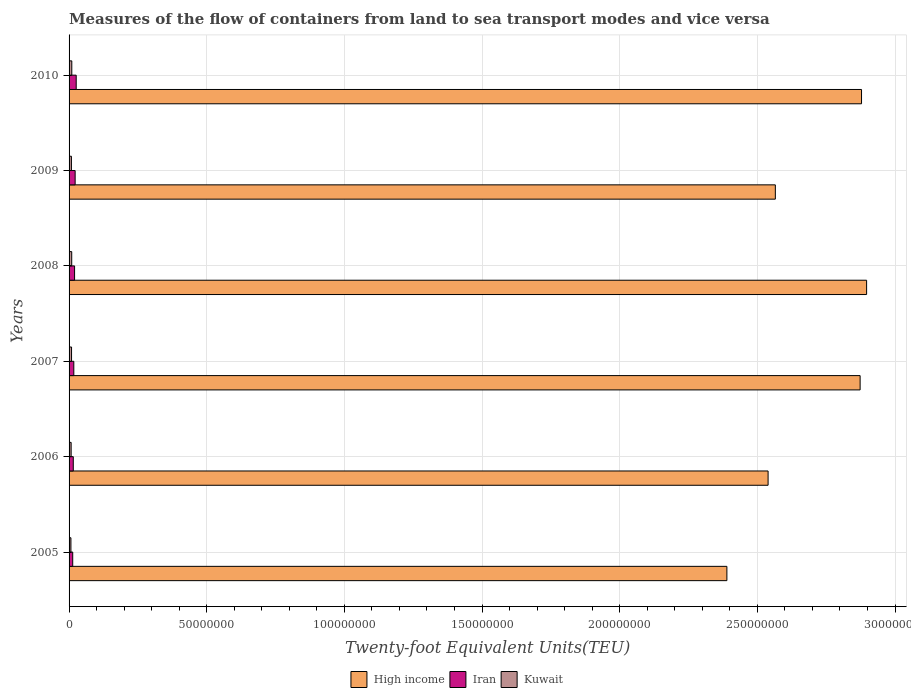How many different coloured bars are there?
Provide a succinct answer. 3. How many groups of bars are there?
Offer a terse response. 6. Are the number of bars per tick equal to the number of legend labels?
Ensure brevity in your answer.  Yes. Are the number of bars on each tick of the Y-axis equal?
Provide a succinct answer. Yes. How many bars are there on the 3rd tick from the top?
Provide a short and direct response. 3. What is the container port traffic in High income in 2006?
Give a very brief answer. 2.54e+08. Across all years, what is the maximum container port traffic in Iran?
Your answer should be very brief. 2.59e+06. Across all years, what is the minimum container port traffic in Kuwait?
Ensure brevity in your answer.  6.73e+05. In which year was the container port traffic in Kuwait maximum?
Make the answer very short. 2010. What is the total container port traffic in High income in the graph?
Provide a short and direct response. 1.61e+09. What is the difference between the container port traffic in Kuwait in 2008 and that in 2009?
Offer a very short reply. 1.08e+05. What is the difference between the container port traffic in High income in 2006 and the container port traffic in Iran in 2005?
Your answer should be compact. 2.53e+08. What is the average container port traffic in Kuwait per year?
Provide a short and direct response. 8.55e+05. In the year 2005, what is the difference between the container port traffic in Iran and container port traffic in Kuwait?
Your answer should be compact. 6.52e+05. In how many years, is the container port traffic in Iran greater than 20000000 TEU?
Your response must be concise. 0. What is the ratio of the container port traffic in High income in 2008 to that in 2009?
Offer a terse response. 1.13. Is the container port traffic in High income in 2006 less than that in 2009?
Provide a short and direct response. Yes. What is the difference between the highest and the second highest container port traffic in Kuwait?
Keep it short and to the point. 2.99e+04. What is the difference between the highest and the lowest container port traffic in Iran?
Give a very brief answer. 1.27e+06. In how many years, is the container port traffic in Iran greater than the average container port traffic in Iran taken over all years?
Provide a short and direct response. 3. Is the sum of the container port traffic in Kuwait in 2006 and 2009 greater than the maximum container port traffic in Iran across all years?
Ensure brevity in your answer.  No. What does the 2nd bar from the top in 2010 represents?
Offer a terse response. Iran. What does the 1st bar from the bottom in 2005 represents?
Offer a terse response. High income. Is it the case that in every year, the sum of the container port traffic in High income and container port traffic in Iran is greater than the container port traffic in Kuwait?
Keep it short and to the point. Yes. How many bars are there?
Ensure brevity in your answer.  18. Are all the bars in the graph horizontal?
Your response must be concise. Yes. How many years are there in the graph?
Give a very brief answer. 6. What is the difference between two consecutive major ticks on the X-axis?
Give a very brief answer. 5.00e+07. Does the graph contain any zero values?
Make the answer very short. No. Does the graph contain grids?
Give a very brief answer. Yes. Where does the legend appear in the graph?
Provide a short and direct response. Bottom center. What is the title of the graph?
Ensure brevity in your answer.  Measures of the flow of containers from land to sea transport modes and vice versa. Does "Kenya" appear as one of the legend labels in the graph?
Your answer should be compact. No. What is the label or title of the X-axis?
Provide a short and direct response. Twenty-foot Equivalent Units(TEU). What is the Twenty-foot Equivalent Units(TEU) in High income in 2005?
Ensure brevity in your answer.  2.39e+08. What is the Twenty-foot Equivalent Units(TEU) in Iran in 2005?
Offer a terse response. 1.33e+06. What is the Twenty-foot Equivalent Units(TEU) of Kuwait in 2005?
Offer a terse response. 6.73e+05. What is the Twenty-foot Equivalent Units(TEU) in High income in 2006?
Provide a short and direct response. 2.54e+08. What is the Twenty-foot Equivalent Units(TEU) of Iran in 2006?
Give a very brief answer. 1.53e+06. What is the Twenty-foot Equivalent Units(TEU) in Kuwait in 2006?
Keep it short and to the point. 7.50e+05. What is the Twenty-foot Equivalent Units(TEU) in High income in 2007?
Provide a succinct answer. 2.87e+08. What is the Twenty-foot Equivalent Units(TEU) of Iran in 2007?
Provide a succinct answer. 1.72e+06. What is the Twenty-foot Equivalent Units(TEU) of Kuwait in 2007?
Provide a short and direct response. 9.00e+05. What is the Twenty-foot Equivalent Units(TEU) in High income in 2008?
Keep it short and to the point. 2.90e+08. What is the Twenty-foot Equivalent Units(TEU) of Iran in 2008?
Your answer should be compact. 2.00e+06. What is the Twenty-foot Equivalent Units(TEU) in Kuwait in 2008?
Offer a very short reply. 9.62e+05. What is the Twenty-foot Equivalent Units(TEU) of High income in 2009?
Your answer should be compact. 2.57e+08. What is the Twenty-foot Equivalent Units(TEU) of Iran in 2009?
Your answer should be very brief. 2.21e+06. What is the Twenty-foot Equivalent Units(TEU) of Kuwait in 2009?
Your answer should be compact. 8.54e+05. What is the Twenty-foot Equivalent Units(TEU) of High income in 2010?
Provide a succinct answer. 2.88e+08. What is the Twenty-foot Equivalent Units(TEU) in Iran in 2010?
Offer a terse response. 2.59e+06. What is the Twenty-foot Equivalent Units(TEU) of Kuwait in 2010?
Provide a short and direct response. 9.92e+05. Across all years, what is the maximum Twenty-foot Equivalent Units(TEU) in High income?
Keep it short and to the point. 2.90e+08. Across all years, what is the maximum Twenty-foot Equivalent Units(TEU) of Iran?
Your response must be concise. 2.59e+06. Across all years, what is the maximum Twenty-foot Equivalent Units(TEU) of Kuwait?
Make the answer very short. 9.92e+05. Across all years, what is the minimum Twenty-foot Equivalent Units(TEU) of High income?
Your answer should be compact. 2.39e+08. Across all years, what is the minimum Twenty-foot Equivalent Units(TEU) in Iran?
Offer a terse response. 1.33e+06. Across all years, what is the minimum Twenty-foot Equivalent Units(TEU) of Kuwait?
Ensure brevity in your answer.  6.73e+05. What is the total Twenty-foot Equivalent Units(TEU) in High income in the graph?
Your response must be concise. 1.61e+09. What is the total Twenty-foot Equivalent Units(TEU) of Iran in the graph?
Your response must be concise. 1.14e+07. What is the total Twenty-foot Equivalent Units(TEU) of Kuwait in the graph?
Provide a short and direct response. 5.13e+06. What is the difference between the Twenty-foot Equivalent Units(TEU) of High income in 2005 and that in 2006?
Your answer should be very brief. -1.50e+07. What is the difference between the Twenty-foot Equivalent Units(TEU) of Iran in 2005 and that in 2006?
Offer a terse response. -2.03e+05. What is the difference between the Twenty-foot Equivalent Units(TEU) of Kuwait in 2005 and that in 2006?
Provide a short and direct response. -7.65e+04. What is the difference between the Twenty-foot Equivalent Units(TEU) in High income in 2005 and that in 2007?
Your answer should be compact. -4.84e+07. What is the difference between the Twenty-foot Equivalent Units(TEU) of Iran in 2005 and that in 2007?
Provide a succinct answer. -3.97e+05. What is the difference between the Twenty-foot Equivalent Units(TEU) of Kuwait in 2005 and that in 2007?
Offer a very short reply. -2.27e+05. What is the difference between the Twenty-foot Equivalent Units(TEU) of High income in 2005 and that in 2008?
Provide a succinct answer. -5.08e+07. What is the difference between the Twenty-foot Equivalent Units(TEU) of Iran in 2005 and that in 2008?
Your response must be concise. -6.75e+05. What is the difference between the Twenty-foot Equivalent Units(TEU) of Kuwait in 2005 and that in 2008?
Ensure brevity in your answer.  -2.88e+05. What is the difference between the Twenty-foot Equivalent Units(TEU) of High income in 2005 and that in 2009?
Your answer should be compact. -1.76e+07. What is the difference between the Twenty-foot Equivalent Units(TEU) in Iran in 2005 and that in 2009?
Offer a terse response. -8.81e+05. What is the difference between the Twenty-foot Equivalent Units(TEU) of Kuwait in 2005 and that in 2009?
Offer a terse response. -1.81e+05. What is the difference between the Twenty-foot Equivalent Units(TEU) in High income in 2005 and that in 2010?
Provide a succinct answer. -4.89e+07. What is the difference between the Twenty-foot Equivalent Units(TEU) of Iran in 2005 and that in 2010?
Offer a terse response. -1.27e+06. What is the difference between the Twenty-foot Equivalent Units(TEU) in Kuwait in 2005 and that in 2010?
Provide a succinct answer. -3.18e+05. What is the difference between the Twenty-foot Equivalent Units(TEU) in High income in 2006 and that in 2007?
Your response must be concise. -3.34e+07. What is the difference between the Twenty-foot Equivalent Units(TEU) of Iran in 2006 and that in 2007?
Your response must be concise. -1.94e+05. What is the difference between the Twenty-foot Equivalent Units(TEU) in Kuwait in 2006 and that in 2007?
Keep it short and to the point. -1.50e+05. What is the difference between the Twenty-foot Equivalent Units(TEU) of High income in 2006 and that in 2008?
Provide a short and direct response. -3.58e+07. What is the difference between the Twenty-foot Equivalent Units(TEU) of Iran in 2006 and that in 2008?
Give a very brief answer. -4.72e+05. What is the difference between the Twenty-foot Equivalent Units(TEU) in Kuwait in 2006 and that in 2008?
Offer a terse response. -2.12e+05. What is the difference between the Twenty-foot Equivalent Units(TEU) in High income in 2006 and that in 2009?
Your response must be concise. -2.63e+06. What is the difference between the Twenty-foot Equivalent Units(TEU) in Iran in 2006 and that in 2009?
Offer a terse response. -6.78e+05. What is the difference between the Twenty-foot Equivalent Units(TEU) of Kuwait in 2006 and that in 2009?
Give a very brief answer. -1.04e+05. What is the difference between the Twenty-foot Equivalent Units(TEU) in High income in 2006 and that in 2010?
Provide a succinct answer. -3.39e+07. What is the difference between the Twenty-foot Equivalent Units(TEU) of Iran in 2006 and that in 2010?
Ensure brevity in your answer.  -1.06e+06. What is the difference between the Twenty-foot Equivalent Units(TEU) in Kuwait in 2006 and that in 2010?
Provide a short and direct response. -2.42e+05. What is the difference between the Twenty-foot Equivalent Units(TEU) of High income in 2007 and that in 2008?
Provide a short and direct response. -2.36e+06. What is the difference between the Twenty-foot Equivalent Units(TEU) in Iran in 2007 and that in 2008?
Ensure brevity in your answer.  -2.78e+05. What is the difference between the Twenty-foot Equivalent Units(TEU) of Kuwait in 2007 and that in 2008?
Your answer should be compact. -6.17e+04. What is the difference between the Twenty-foot Equivalent Units(TEU) in High income in 2007 and that in 2009?
Make the answer very short. 3.08e+07. What is the difference between the Twenty-foot Equivalent Units(TEU) of Iran in 2007 and that in 2009?
Your answer should be compact. -4.84e+05. What is the difference between the Twenty-foot Equivalent Units(TEU) of Kuwait in 2007 and that in 2009?
Your answer should be very brief. 4.60e+04. What is the difference between the Twenty-foot Equivalent Units(TEU) in High income in 2007 and that in 2010?
Your answer should be compact. -5.10e+05. What is the difference between the Twenty-foot Equivalent Units(TEU) of Iran in 2007 and that in 2010?
Offer a very short reply. -8.70e+05. What is the difference between the Twenty-foot Equivalent Units(TEU) of Kuwait in 2007 and that in 2010?
Your response must be concise. -9.15e+04. What is the difference between the Twenty-foot Equivalent Units(TEU) of High income in 2008 and that in 2009?
Your response must be concise. 3.32e+07. What is the difference between the Twenty-foot Equivalent Units(TEU) of Iran in 2008 and that in 2009?
Provide a short and direct response. -2.06e+05. What is the difference between the Twenty-foot Equivalent Units(TEU) in Kuwait in 2008 and that in 2009?
Offer a very short reply. 1.08e+05. What is the difference between the Twenty-foot Equivalent Units(TEU) in High income in 2008 and that in 2010?
Offer a very short reply. 1.85e+06. What is the difference between the Twenty-foot Equivalent Units(TEU) of Iran in 2008 and that in 2010?
Your response must be concise. -5.92e+05. What is the difference between the Twenty-foot Equivalent Units(TEU) in Kuwait in 2008 and that in 2010?
Offer a very short reply. -2.99e+04. What is the difference between the Twenty-foot Equivalent Units(TEU) of High income in 2009 and that in 2010?
Ensure brevity in your answer.  -3.13e+07. What is the difference between the Twenty-foot Equivalent Units(TEU) of Iran in 2009 and that in 2010?
Give a very brief answer. -3.86e+05. What is the difference between the Twenty-foot Equivalent Units(TEU) of Kuwait in 2009 and that in 2010?
Your answer should be very brief. -1.38e+05. What is the difference between the Twenty-foot Equivalent Units(TEU) of High income in 2005 and the Twenty-foot Equivalent Units(TEU) of Iran in 2006?
Provide a short and direct response. 2.37e+08. What is the difference between the Twenty-foot Equivalent Units(TEU) of High income in 2005 and the Twenty-foot Equivalent Units(TEU) of Kuwait in 2006?
Your answer should be very brief. 2.38e+08. What is the difference between the Twenty-foot Equivalent Units(TEU) in Iran in 2005 and the Twenty-foot Equivalent Units(TEU) in Kuwait in 2006?
Keep it short and to the point. 5.76e+05. What is the difference between the Twenty-foot Equivalent Units(TEU) of High income in 2005 and the Twenty-foot Equivalent Units(TEU) of Iran in 2007?
Your response must be concise. 2.37e+08. What is the difference between the Twenty-foot Equivalent Units(TEU) of High income in 2005 and the Twenty-foot Equivalent Units(TEU) of Kuwait in 2007?
Give a very brief answer. 2.38e+08. What is the difference between the Twenty-foot Equivalent Units(TEU) of Iran in 2005 and the Twenty-foot Equivalent Units(TEU) of Kuwait in 2007?
Provide a succinct answer. 4.26e+05. What is the difference between the Twenty-foot Equivalent Units(TEU) of High income in 2005 and the Twenty-foot Equivalent Units(TEU) of Iran in 2008?
Keep it short and to the point. 2.37e+08. What is the difference between the Twenty-foot Equivalent Units(TEU) of High income in 2005 and the Twenty-foot Equivalent Units(TEU) of Kuwait in 2008?
Provide a succinct answer. 2.38e+08. What is the difference between the Twenty-foot Equivalent Units(TEU) of Iran in 2005 and the Twenty-foot Equivalent Units(TEU) of Kuwait in 2008?
Keep it short and to the point. 3.64e+05. What is the difference between the Twenty-foot Equivalent Units(TEU) in High income in 2005 and the Twenty-foot Equivalent Units(TEU) in Iran in 2009?
Offer a very short reply. 2.37e+08. What is the difference between the Twenty-foot Equivalent Units(TEU) in High income in 2005 and the Twenty-foot Equivalent Units(TEU) in Kuwait in 2009?
Offer a terse response. 2.38e+08. What is the difference between the Twenty-foot Equivalent Units(TEU) in Iran in 2005 and the Twenty-foot Equivalent Units(TEU) in Kuwait in 2009?
Offer a terse response. 4.72e+05. What is the difference between the Twenty-foot Equivalent Units(TEU) of High income in 2005 and the Twenty-foot Equivalent Units(TEU) of Iran in 2010?
Your answer should be compact. 2.36e+08. What is the difference between the Twenty-foot Equivalent Units(TEU) of High income in 2005 and the Twenty-foot Equivalent Units(TEU) of Kuwait in 2010?
Provide a succinct answer. 2.38e+08. What is the difference between the Twenty-foot Equivalent Units(TEU) of Iran in 2005 and the Twenty-foot Equivalent Units(TEU) of Kuwait in 2010?
Your answer should be compact. 3.34e+05. What is the difference between the Twenty-foot Equivalent Units(TEU) in High income in 2006 and the Twenty-foot Equivalent Units(TEU) in Iran in 2007?
Provide a succinct answer. 2.52e+08. What is the difference between the Twenty-foot Equivalent Units(TEU) in High income in 2006 and the Twenty-foot Equivalent Units(TEU) in Kuwait in 2007?
Offer a terse response. 2.53e+08. What is the difference between the Twenty-foot Equivalent Units(TEU) of Iran in 2006 and the Twenty-foot Equivalent Units(TEU) of Kuwait in 2007?
Provide a short and direct response. 6.29e+05. What is the difference between the Twenty-foot Equivalent Units(TEU) of High income in 2006 and the Twenty-foot Equivalent Units(TEU) of Iran in 2008?
Give a very brief answer. 2.52e+08. What is the difference between the Twenty-foot Equivalent Units(TEU) of High income in 2006 and the Twenty-foot Equivalent Units(TEU) of Kuwait in 2008?
Your answer should be compact. 2.53e+08. What is the difference between the Twenty-foot Equivalent Units(TEU) in Iran in 2006 and the Twenty-foot Equivalent Units(TEU) in Kuwait in 2008?
Make the answer very short. 5.67e+05. What is the difference between the Twenty-foot Equivalent Units(TEU) in High income in 2006 and the Twenty-foot Equivalent Units(TEU) in Iran in 2009?
Make the answer very short. 2.52e+08. What is the difference between the Twenty-foot Equivalent Units(TEU) in High income in 2006 and the Twenty-foot Equivalent Units(TEU) in Kuwait in 2009?
Provide a short and direct response. 2.53e+08. What is the difference between the Twenty-foot Equivalent Units(TEU) of Iran in 2006 and the Twenty-foot Equivalent Units(TEU) of Kuwait in 2009?
Your answer should be very brief. 6.74e+05. What is the difference between the Twenty-foot Equivalent Units(TEU) of High income in 2006 and the Twenty-foot Equivalent Units(TEU) of Iran in 2010?
Provide a short and direct response. 2.51e+08. What is the difference between the Twenty-foot Equivalent Units(TEU) of High income in 2006 and the Twenty-foot Equivalent Units(TEU) of Kuwait in 2010?
Your answer should be very brief. 2.53e+08. What is the difference between the Twenty-foot Equivalent Units(TEU) of Iran in 2006 and the Twenty-foot Equivalent Units(TEU) of Kuwait in 2010?
Your answer should be compact. 5.37e+05. What is the difference between the Twenty-foot Equivalent Units(TEU) in High income in 2007 and the Twenty-foot Equivalent Units(TEU) in Iran in 2008?
Make the answer very short. 2.85e+08. What is the difference between the Twenty-foot Equivalent Units(TEU) of High income in 2007 and the Twenty-foot Equivalent Units(TEU) of Kuwait in 2008?
Make the answer very short. 2.86e+08. What is the difference between the Twenty-foot Equivalent Units(TEU) in Iran in 2007 and the Twenty-foot Equivalent Units(TEU) in Kuwait in 2008?
Offer a terse response. 7.61e+05. What is the difference between the Twenty-foot Equivalent Units(TEU) in High income in 2007 and the Twenty-foot Equivalent Units(TEU) in Iran in 2009?
Your answer should be compact. 2.85e+08. What is the difference between the Twenty-foot Equivalent Units(TEU) of High income in 2007 and the Twenty-foot Equivalent Units(TEU) of Kuwait in 2009?
Make the answer very short. 2.86e+08. What is the difference between the Twenty-foot Equivalent Units(TEU) in Iran in 2007 and the Twenty-foot Equivalent Units(TEU) in Kuwait in 2009?
Your answer should be very brief. 8.68e+05. What is the difference between the Twenty-foot Equivalent Units(TEU) of High income in 2007 and the Twenty-foot Equivalent Units(TEU) of Iran in 2010?
Provide a short and direct response. 2.85e+08. What is the difference between the Twenty-foot Equivalent Units(TEU) of High income in 2007 and the Twenty-foot Equivalent Units(TEU) of Kuwait in 2010?
Your answer should be compact. 2.86e+08. What is the difference between the Twenty-foot Equivalent Units(TEU) in Iran in 2007 and the Twenty-foot Equivalent Units(TEU) in Kuwait in 2010?
Offer a very short reply. 7.31e+05. What is the difference between the Twenty-foot Equivalent Units(TEU) in High income in 2008 and the Twenty-foot Equivalent Units(TEU) in Iran in 2009?
Offer a very short reply. 2.87e+08. What is the difference between the Twenty-foot Equivalent Units(TEU) of High income in 2008 and the Twenty-foot Equivalent Units(TEU) of Kuwait in 2009?
Offer a very short reply. 2.89e+08. What is the difference between the Twenty-foot Equivalent Units(TEU) of Iran in 2008 and the Twenty-foot Equivalent Units(TEU) of Kuwait in 2009?
Make the answer very short. 1.15e+06. What is the difference between the Twenty-foot Equivalent Units(TEU) of High income in 2008 and the Twenty-foot Equivalent Units(TEU) of Iran in 2010?
Ensure brevity in your answer.  2.87e+08. What is the difference between the Twenty-foot Equivalent Units(TEU) in High income in 2008 and the Twenty-foot Equivalent Units(TEU) in Kuwait in 2010?
Keep it short and to the point. 2.89e+08. What is the difference between the Twenty-foot Equivalent Units(TEU) in Iran in 2008 and the Twenty-foot Equivalent Units(TEU) in Kuwait in 2010?
Your answer should be very brief. 1.01e+06. What is the difference between the Twenty-foot Equivalent Units(TEU) of High income in 2009 and the Twenty-foot Equivalent Units(TEU) of Iran in 2010?
Ensure brevity in your answer.  2.54e+08. What is the difference between the Twenty-foot Equivalent Units(TEU) in High income in 2009 and the Twenty-foot Equivalent Units(TEU) in Kuwait in 2010?
Offer a very short reply. 2.56e+08. What is the difference between the Twenty-foot Equivalent Units(TEU) of Iran in 2009 and the Twenty-foot Equivalent Units(TEU) of Kuwait in 2010?
Your answer should be very brief. 1.21e+06. What is the average Twenty-foot Equivalent Units(TEU) in High income per year?
Your answer should be compact. 2.69e+08. What is the average Twenty-foot Equivalent Units(TEU) in Iran per year?
Offer a terse response. 1.90e+06. What is the average Twenty-foot Equivalent Units(TEU) in Kuwait per year?
Make the answer very short. 8.55e+05. In the year 2005, what is the difference between the Twenty-foot Equivalent Units(TEU) of High income and Twenty-foot Equivalent Units(TEU) of Iran?
Your answer should be very brief. 2.38e+08. In the year 2005, what is the difference between the Twenty-foot Equivalent Units(TEU) in High income and Twenty-foot Equivalent Units(TEU) in Kuwait?
Your response must be concise. 2.38e+08. In the year 2005, what is the difference between the Twenty-foot Equivalent Units(TEU) of Iran and Twenty-foot Equivalent Units(TEU) of Kuwait?
Keep it short and to the point. 6.52e+05. In the year 2006, what is the difference between the Twenty-foot Equivalent Units(TEU) of High income and Twenty-foot Equivalent Units(TEU) of Iran?
Keep it short and to the point. 2.52e+08. In the year 2006, what is the difference between the Twenty-foot Equivalent Units(TEU) in High income and Twenty-foot Equivalent Units(TEU) in Kuwait?
Your answer should be compact. 2.53e+08. In the year 2006, what is the difference between the Twenty-foot Equivalent Units(TEU) of Iran and Twenty-foot Equivalent Units(TEU) of Kuwait?
Make the answer very short. 7.79e+05. In the year 2007, what is the difference between the Twenty-foot Equivalent Units(TEU) in High income and Twenty-foot Equivalent Units(TEU) in Iran?
Give a very brief answer. 2.86e+08. In the year 2007, what is the difference between the Twenty-foot Equivalent Units(TEU) in High income and Twenty-foot Equivalent Units(TEU) in Kuwait?
Offer a very short reply. 2.86e+08. In the year 2007, what is the difference between the Twenty-foot Equivalent Units(TEU) in Iran and Twenty-foot Equivalent Units(TEU) in Kuwait?
Your answer should be compact. 8.23e+05. In the year 2008, what is the difference between the Twenty-foot Equivalent Units(TEU) in High income and Twenty-foot Equivalent Units(TEU) in Iran?
Give a very brief answer. 2.88e+08. In the year 2008, what is the difference between the Twenty-foot Equivalent Units(TEU) of High income and Twenty-foot Equivalent Units(TEU) of Kuwait?
Your answer should be compact. 2.89e+08. In the year 2008, what is the difference between the Twenty-foot Equivalent Units(TEU) of Iran and Twenty-foot Equivalent Units(TEU) of Kuwait?
Ensure brevity in your answer.  1.04e+06. In the year 2009, what is the difference between the Twenty-foot Equivalent Units(TEU) in High income and Twenty-foot Equivalent Units(TEU) in Iran?
Ensure brevity in your answer.  2.54e+08. In the year 2009, what is the difference between the Twenty-foot Equivalent Units(TEU) in High income and Twenty-foot Equivalent Units(TEU) in Kuwait?
Keep it short and to the point. 2.56e+08. In the year 2009, what is the difference between the Twenty-foot Equivalent Units(TEU) of Iran and Twenty-foot Equivalent Units(TEU) of Kuwait?
Your response must be concise. 1.35e+06. In the year 2010, what is the difference between the Twenty-foot Equivalent Units(TEU) of High income and Twenty-foot Equivalent Units(TEU) of Iran?
Give a very brief answer. 2.85e+08. In the year 2010, what is the difference between the Twenty-foot Equivalent Units(TEU) in High income and Twenty-foot Equivalent Units(TEU) in Kuwait?
Ensure brevity in your answer.  2.87e+08. In the year 2010, what is the difference between the Twenty-foot Equivalent Units(TEU) of Iran and Twenty-foot Equivalent Units(TEU) of Kuwait?
Your answer should be compact. 1.60e+06. What is the ratio of the Twenty-foot Equivalent Units(TEU) of High income in 2005 to that in 2006?
Keep it short and to the point. 0.94. What is the ratio of the Twenty-foot Equivalent Units(TEU) of Iran in 2005 to that in 2006?
Provide a short and direct response. 0.87. What is the ratio of the Twenty-foot Equivalent Units(TEU) of Kuwait in 2005 to that in 2006?
Your answer should be very brief. 0.9. What is the ratio of the Twenty-foot Equivalent Units(TEU) of High income in 2005 to that in 2007?
Provide a short and direct response. 0.83. What is the ratio of the Twenty-foot Equivalent Units(TEU) in Iran in 2005 to that in 2007?
Make the answer very short. 0.77. What is the ratio of the Twenty-foot Equivalent Units(TEU) in Kuwait in 2005 to that in 2007?
Offer a very short reply. 0.75. What is the ratio of the Twenty-foot Equivalent Units(TEU) of High income in 2005 to that in 2008?
Provide a short and direct response. 0.82. What is the ratio of the Twenty-foot Equivalent Units(TEU) of Iran in 2005 to that in 2008?
Offer a terse response. 0.66. What is the ratio of the Twenty-foot Equivalent Units(TEU) of Kuwait in 2005 to that in 2008?
Provide a succinct answer. 0.7. What is the ratio of the Twenty-foot Equivalent Units(TEU) in High income in 2005 to that in 2009?
Your answer should be very brief. 0.93. What is the ratio of the Twenty-foot Equivalent Units(TEU) in Iran in 2005 to that in 2009?
Make the answer very short. 0.6. What is the ratio of the Twenty-foot Equivalent Units(TEU) of Kuwait in 2005 to that in 2009?
Keep it short and to the point. 0.79. What is the ratio of the Twenty-foot Equivalent Units(TEU) of High income in 2005 to that in 2010?
Your response must be concise. 0.83. What is the ratio of the Twenty-foot Equivalent Units(TEU) in Iran in 2005 to that in 2010?
Provide a succinct answer. 0.51. What is the ratio of the Twenty-foot Equivalent Units(TEU) of Kuwait in 2005 to that in 2010?
Ensure brevity in your answer.  0.68. What is the ratio of the Twenty-foot Equivalent Units(TEU) of High income in 2006 to that in 2007?
Provide a short and direct response. 0.88. What is the ratio of the Twenty-foot Equivalent Units(TEU) in Iran in 2006 to that in 2007?
Ensure brevity in your answer.  0.89. What is the ratio of the Twenty-foot Equivalent Units(TEU) in Kuwait in 2006 to that in 2007?
Offer a very short reply. 0.83. What is the ratio of the Twenty-foot Equivalent Units(TEU) of High income in 2006 to that in 2008?
Ensure brevity in your answer.  0.88. What is the ratio of the Twenty-foot Equivalent Units(TEU) in Iran in 2006 to that in 2008?
Keep it short and to the point. 0.76. What is the ratio of the Twenty-foot Equivalent Units(TEU) of Kuwait in 2006 to that in 2008?
Make the answer very short. 0.78. What is the ratio of the Twenty-foot Equivalent Units(TEU) of High income in 2006 to that in 2009?
Ensure brevity in your answer.  0.99. What is the ratio of the Twenty-foot Equivalent Units(TEU) in Iran in 2006 to that in 2009?
Give a very brief answer. 0.69. What is the ratio of the Twenty-foot Equivalent Units(TEU) in Kuwait in 2006 to that in 2009?
Give a very brief answer. 0.88. What is the ratio of the Twenty-foot Equivalent Units(TEU) in High income in 2006 to that in 2010?
Offer a very short reply. 0.88. What is the ratio of the Twenty-foot Equivalent Units(TEU) in Iran in 2006 to that in 2010?
Offer a terse response. 0.59. What is the ratio of the Twenty-foot Equivalent Units(TEU) in Kuwait in 2006 to that in 2010?
Your answer should be very brief. 0.76. What is the ratio of the Twenty-foot Equivalent Units(TEU) in Iran in 2007 to that in 2008?
Offer a terse response. 0.86. What is the ratio of the Twenty-foot Equivalent Units(TEU) in Kuwait in 2007 to that in 2008?
Ensure brevity in your answer.  0.94. What is the ratio of the Twenty-foot Equivalent Units(TEU) of High income in 2007 to that in 2009?
Your answer should be compact. 1.12. What is the ratio of the Twenty-foot Equivalent Units(TEU) in Iran in 2007 to that in 2009?
Keep it short and to the point. 0.78. What is the ratio of the Twenty-foot Equivalent Units(TEU) of Kuwait in 2007 to that in 2009?
Keep it short and to the point. 1.05. What is the ratio of the Twenty-foot Equivalent Units(TEU) in Iran in 2007 to that in 2010?
Ensure brevity in your answer.  0.66. What is the ratio of the Twenty-foot Equivalent Units(TEU) in Kuwait in 2007 to that in 2010?
Offer a very short reply. 0.91. What is the ratio of the Twenty-foot Equivalent Units(TEU) of High income in 2008 to that in 2009?
Offer a very short reply. 1.13. What is the ratio of the Twenty-foot Equivalent Units(TEU) of Iran in 2008 to that in 2009?
Offer a terse response. 0.91. What is the ratio of the Twenty-foot Equivalent Units(TEU) of Kuwait in 2008 to that in 2009?
Offer a very short reply. 1.13. What is the ratio of the Twenty-foot Equivalent Units(TEU) of High income in 2008 to that in 2010?
Offer a terse response. 1.01. What is the ratio of the Twenty-foot Equivalent Units(TEU) of Iran in 2008 to that in 2010?
Your answer should be very brief. 0.77. What is the ratio of the Twenty-foot Equivalent Units(TEU) in Kuwait in 2008 to that in 2010?
Provide a succinct answer. 0.97. What is the ratio of the Twenty-foot Equivalent Units(TEU) in High income in 2009 to that in 2010?
Offer a very short reply. 0.89. What is the ratio of the Twenty-foot Equivalent Units(TEU) in Iran in 2009 to that in 2010?
Your answer should be compact. 0.85. What is the ratio of the Twenty-foot Equivalent Units(TEU) of Kuwait in 2009 to that in 2010?
Your answer should be very brief. 0.86. What is the difference between the highest and the second highest Twenty-foot Equivalent Units(TEU) in High income?
Your answer should be very brief. 1.85e+06. What is the difference between the highest and the second highest Twenty-foot Equivalent Units(TEU) of Iran?
Your response must be concise. 3.86e+05. What is the difference between the highest and the second highest Twenty-foot Equivalent Units(TEU) of Kuwait?
Your answer should be compact. 2.99e+04. What is the difference between the highest and the lowest Twenty-foot Equivalent Units(TEU) in High income?
Ensure brevity in your answer.  5.08e+07. What is the difference between the highest and the lowest Twenty-foot Equivalent Units(TEU) in Iran?
Offer a very short reply. 1.27e+06. What is the difference between the highest and the lowest Twenty-foot Equivalent Units(TEU) of Kuwait?
Your answer should be compact. 3.18e+05. 